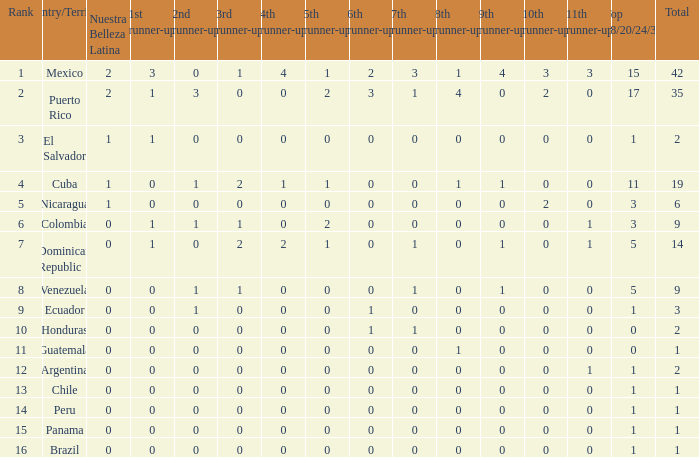What is the 9th runner-up with a top 18/20/24/30 greater than 17 and a 5th runner-up of 2? None. 